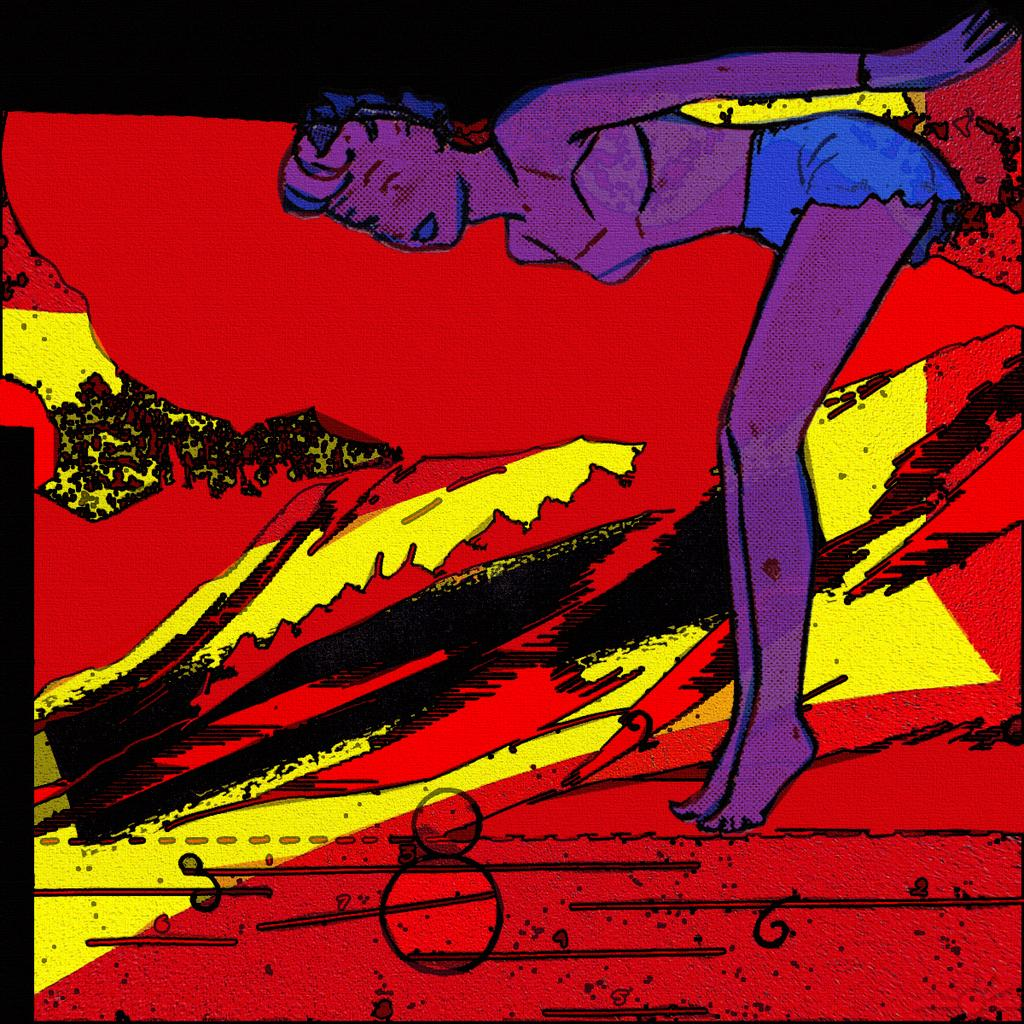What type of artwork is depicted in the image? The image is a painting. Who or what is the main subject in the painting? There is a lady in the painting. Can you describe anything in the background of the painting? There is an object in the background of the painting. What type of honey can be seen dripping from the lady's hair in the painting? There is no honey present in the painting, nor is there any indication of it dripping from the lady's hair. How many twigs are visible in the lady's hand in the painting? There are no twigs visible in the lady's hand in the painting. 